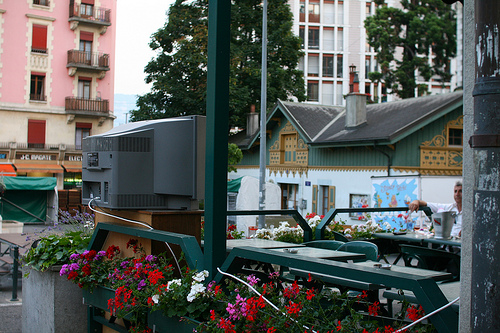<image>
Is the television next to the flowers? Yes. The television is positioned adjacent to the flowers, located nearby in the same general area. 